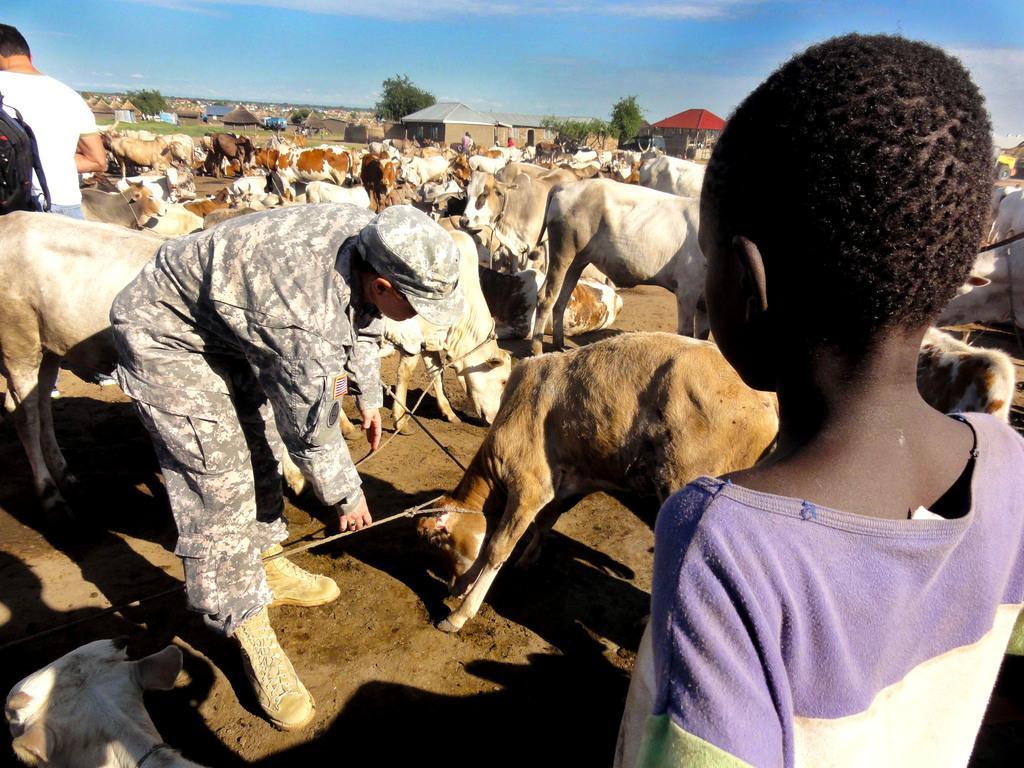In one or two sentences, can you explain what this image depicts? In this picture we can observe humans and animals on the ground. There are some cows and calves in this picture. In the background there are houses and trees. There is a sky in the background. 